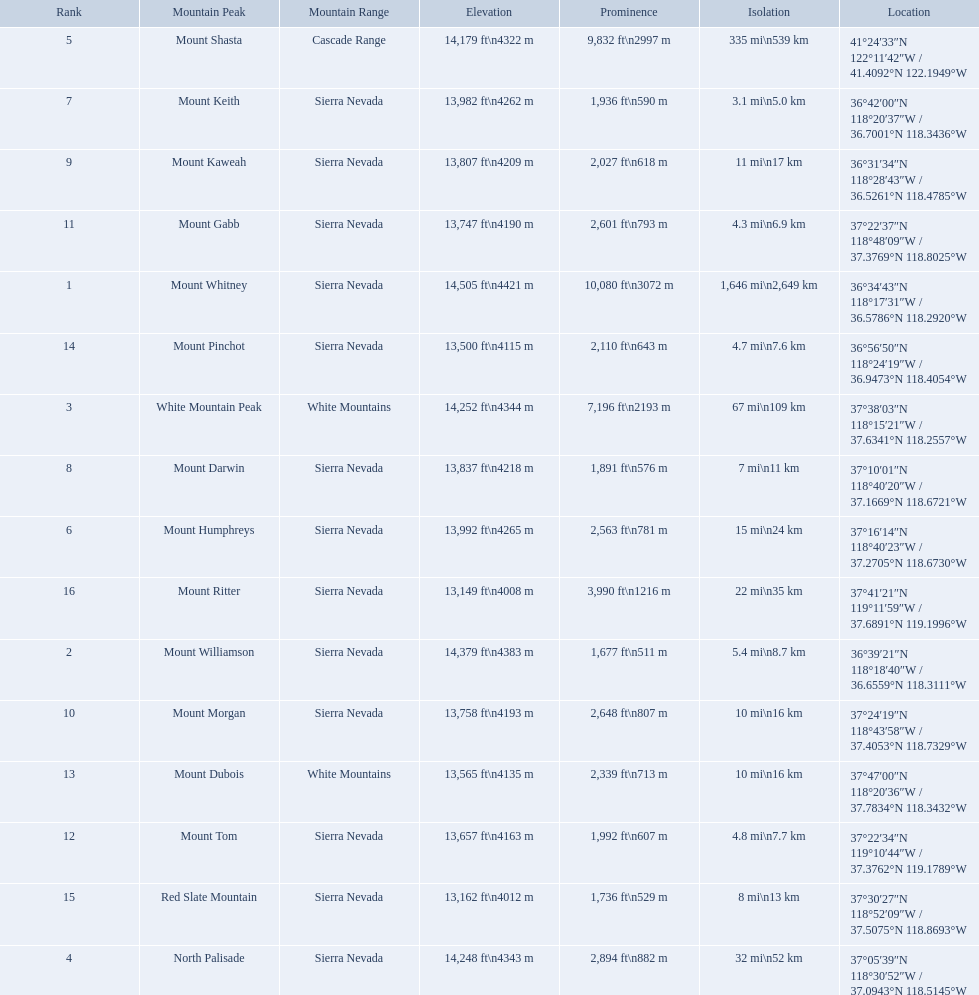What are the mountain peaks? Mount Whitney, Mount Williamson, White Mountain Peak, North Palisade, Mount Shasta, Mount Humphreys, Mount Keith, Mount Darwin, Mount Kaweah, Mount Morgan, Mount Gabb, Mount Tom, Mount Dubois, Mount Pinchot, Red Slate Mountain, Mount Ritter. Of these, which one has a prominence more than 10,000 ft? Mount Whitney. 